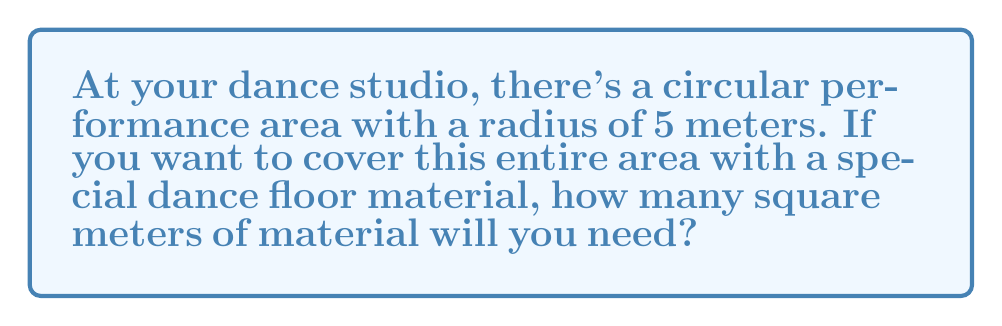Can you answer this question? Let's solve this step-by-step:

1) The formula for the area of a circle is:
   $$A = \pi r^2$$
   Where $A$ is the area and $r$ is the radius.

2) We're given that the radius is 5 meters.

3) Let's substitute this into our formula:
   $$A = \pi (5)^2$$

4) Simplify the squared term:
   $$A = \pi (25)$$

5) Now, let's use 3.14 as an approximation for $\pi$:
   $$A = 3.14 \times 25$$

6) Calculate:
   $$A = 78.5\text{ m}^2$$

Therefore, you'll need approximately 78.5 square meters of material to cover the circular dance floor.
Answer: $78.5\text{ m}^2$ 